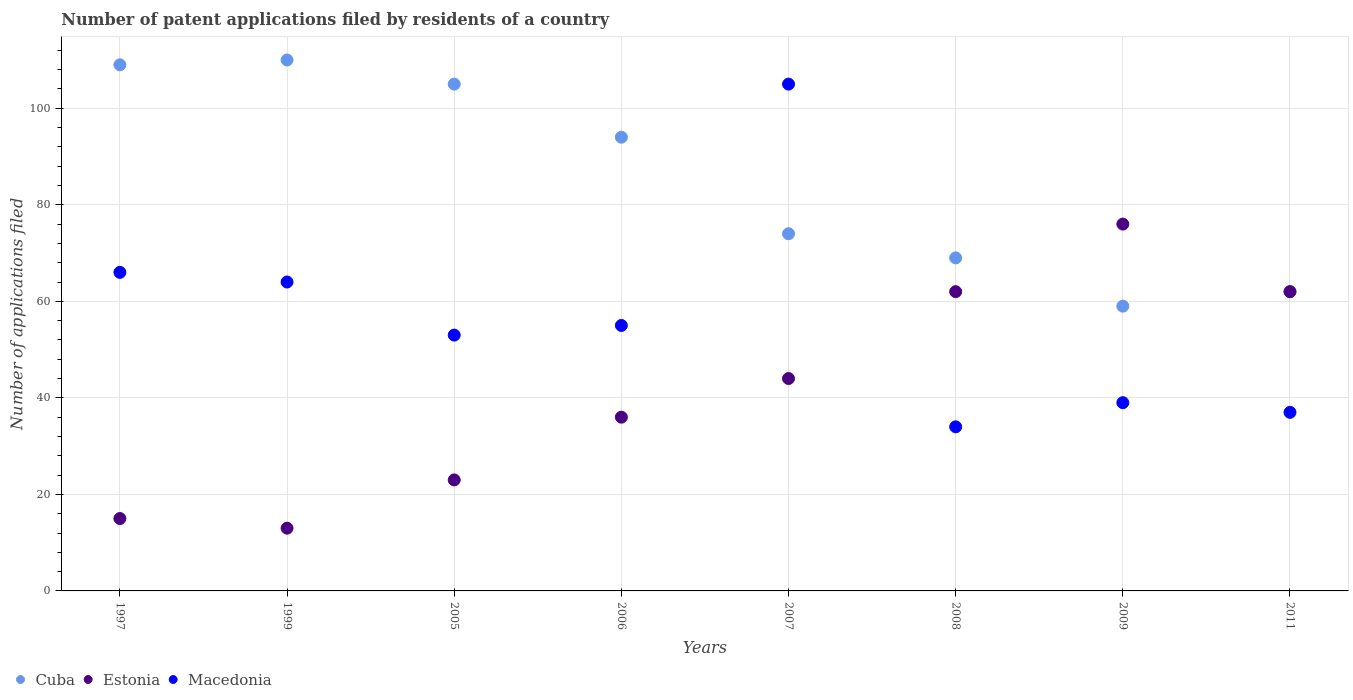How many different coloured dotlines are there?
Make the answer very short. 3. What is the number of applications filed in Cuba in 2009?
Provide a succinct answer. 59. Across all years, what is the minimum number of applications filed in Estonia?
Your answer should be very brief. 13. In which year was the number of applications filed in Cuba maximum?
Offer a very short reply. 1999. In which year was the number of applications filed in Estonia minimum?
Your response must be concise. 1999. What is the total number of applications filed in Macedonia in the graph?
Offer a terse response. 453. What is the difference between the number of applications filed in Estonia in 2008 and that in 2011?
Your response must be concise. 0. What is the average number of applications filed in Estonia per year?
Ensure brevity in your answer.  41.38. In the year 2009, what is the difference between the number of applications filed in Cuba and number of applications filed in Estonia?
Ensure brevity in your answer.  -17. What is the ratio of the number of applications filed in Cuba in 1997 to that in 2006?
Your answer should be compact. 1.16. Is the difference between the number of applications filed in Cuba in 2008 and 2009 greater than the difference between the number of applications filed in Estonia in 2008 and 2009?
Give a very brief answer. Yes. What is the difference between the highest and the lowest number of applications filed in Macedonia?
Your response must be concise. 71. In how many years, is the number of applications filed in Macedonia greater than the average number of applications filed in Macedonia taken over all years?
Make the answer very short. 3. Is the sum of the number of applications filed in Estonia in 1997 and 2008 greater than the maximum number of applications filed in Macedonia across all years?
Give a very brief answer. No. Is it the case that in every year, the sum of the number of applications filed in Estonia and number of applications filed in Cuba  is greater than the number of applications filed in Macedonia?
Your answer should be very brief. Yes. Does the number of applications filed in Estonia monotonically increase over the years?
Your answer should be compact. No. Is the number of applications filed in Cuba strictly greater than the number of applications filed in Estonia over the years?
Your response must be concise. No. How many dotlines are there?
Your answer should be very brief. 3. How many years are there in the graph?
Provide a short and direct response. 8. What is the difference between two consecutive major ticks on the Y-axis?
Your answer should be very brief. 20. Does the graph contain any zero values?
Provide a succinct answer. No. What is the title of the graph?
Provide a succinct answer. Number of patent applications filed by residents of a country. Does "Iran" appear as one of the legend labels in the graph?
Offer a terse response. No. What is the label or title of the Y-axis?
Your response must be concise. Number of applications filed. What is the Number of applications filed in Cuba in 1997?
Your response must be concise. 109. What is the Number of applications filed in Estonia in 1997?
Offer a very short reply. 15. What is the Number of applications filed in Cuba in 1999?
Give a very brief answer. 110. What is the Number of applications filed of Macedonia in 1999?
Keep it short and to the point. 64. What is the Number of applications filed in Cuba in 2005?
Your answer should be compact. 105. What is the Number of applications filed in Estonia in 2005?
Give a very brief answer. 23. What is the Number of applications filed of Macedonia in 2005?
Give a very brief answer. 53. What is the Number of applications filed of Cuba in 2006?
Your response must be concise. 94. What is the Number of applications filed of Cuba in 2007?
Ensure brevity in your answer.  74. What is the Number of applications filed in Estonia in 2007?
Provide a succinct answer. 44. What is the Number of applications filed in Macedonia in 2007?
Provide a short and direct response. 105. What is the Number of applications filed in Cuba in 2009?
Make the answer very short. 59. What is the Number of applications filed of Cuba in 2011?
Offer a very short reply. 62. What is the Number of applications filed in Macedonia in 2011?
Keep it short and to the point. 37. Across all years, what is the maximum Number of applications filed of Cuba?
Offer a very short reply. 110. Across all years, what is the maximum Number of applications filed in Macedonia?
Ensure brevity in your answer.  105. Across all years, what is the minimum Number of applications filed of Estonia?
Offer a very short reply. 13. Across all years, what is the minimum Number of applications filed in Macedonia?
Your response must be concise. 34. What is the total Number of applications filed of Cuba in the graph?
Ensure brevity in your answer.  682. What is the total Number of applications filed of Estonia in the graph?
Your answer should be compact. 331. What is the total Number of applications filed in Macedonia in the graph?
Ensure brevity in your answer.  453. What is the difference between the Number of applications filed in Estonia in 1997 and that in 1999?
Give a very brief answer. 2. What is the difference between the Number of applications filed of Macedonia in 1997 and that in 1999?
Ensure brevity in your answer.  2. What is the difference between the Number of applications filed in Estonia in 1997 and that in 2006?
Provide a succinct answer. -21. What is the difference between the Number of applications filed of Estonia in 1997 and that in 2007?
Your answer should be very brief. -29. What is the difference between the Number of applications filed of Macedonia in 1997 and that in 2007?
Ensure brevity in your answer.  -39. What is the difference between the Number of applications filed of Cuba in 1997 and that in 2008?
Keep it short and to the point. 40. What is the difference between the Number of applications filed in Estonia in 1997 and that in 2008?
Ensure brevity in your answer.  -47. What is the difference between the Number of applications filed in Macedonia in 1997 and that in 2008?
Offer a very short reply. 32. What is the difference between the Number of applications filed of Cuba in 1997 and that in 2009?
Your answer should be very brief. 50. What is the difference between the Number of applications filed in Estonia in 1997 and that in 2009?
Ensure brevity in your answer.  -61. What is the difference between the Number of applications filed in Macedonia in 1997 and that in 2009?
Your response must be concise. 27. What is the difference between the Number of applications filed of Cuba in 1997 and that in 2011?
Provide a succinct answer. 47. What is the difference between the Number of applications filed in Estonia in 1997 and that in 2011?
Your answer should be very brief. -47. What is the difference between the Number of applications filed in Macedonia in 1997 and that in 2011?
Ensure brevity in your answer.  29. What is the difference between the Number of applications filed of Cuba in 1999 and that in 2005?
Ensure brevity in your answer.  5. What is the difference between the Number of applications filed of Estonia in 1999 and that in 2005?
Your answer should be compact. -10. What is the difference between the Number of applications filed in Cuba in 1999 and that in 2006?
Your answer should be compact. 16. What is the difference between the Number of applications filed in Estonia in 1999 and that in 2006?
Ensure brevity in your answer.  -23. What is the difference between the Number of applications filed in Estonia in 1999 and that in 2007?
Your response must be concise. -31. What is the difference between the Number of applications filed in Macedonia in 1999 and that in 2007?
Make the answer very short. -41. What is the difference between the Number of applications filed in Cuba in 1999 and that in 2008?
Offer a very short reply. 41. What is the difference between the Number of applications filed in Estonia in 1999 and that in 2008?
Offer a very short reply. -49. What is the difference between the Number of applications filed of Macedonia in 1999 and that in 2008?
Make the answer very short. 30. What is the difference between the Number of applications filed in Cuba in 1999 and that in 2009?
Offer a very short reply. 51. What is the difference between the Number of applications filed of Estonia in 1999 and that in 2009?
Your response must be concise. -63. What is the difference between the Number of applications filed of Estonia in 1999 and that in 2011?
Your answer should be compact. -49. What is the difference between the Number of applications filed in Macedonia in 1999 and that in 2011?
Your answer should be very brief. 27. What is the difference between the Number of applications filed of Cuba in 2005 and that in 2007?
Offer a terse response. 31. What is the difference between the Number of applications filed of Estonia in 2005 and that in 2007?
Ensure brevity in your answer.  -21. What is the difference between the Number of applications filed of Macedonia in 2005 and that in 2007?
Ensure brevity in your answer.  -52. What is the difference between the Number of applications filed of Estonia in 2005 and that in 2008?
Offer a very short reply. -39. What is the difference between the Number of applications filed in Macedonia in 2005 and that in 2008?
Offer a very short reply. 19. What is the difference between the Number of applications filed of Estonia in 2005 and that in 2009?
Keep it short and to the point. -53. What is the difference between the Number of applications filed of Cuba in 2005 and that in 2011?
Keep it short and to the point. 43. What is the difference between the Number of applications filed in Estonia in 2005 and that in 2011?
Provide a short and direct response. -39. What is the difference between the Number of applications filed of Macedonia in 2005 and that in 2011?
Provide a succinct answer. 16. What is the difference between the Number of applications filed in Cuba in 2006 and that in 2007?
Offer a very short reply. 20. What is the difference between the Number of applications filed in Estonia in 2006 and that in 2007?
Your response must be concise. -8. What is the difference between the Number of applications filed of Cuba in 2006 and that in 2008?
Keep it short and to the point. 25. What is the difference between the Number of applications filed of Estonia in 2006 and that in 2008?
Keep it short and to the point. -26. What is the difference between the Number of applications filed of Macedonia in 2006 and that in 2008?
Ensure brevity in your answer.  21. What is the difference between the Number of applications filed in Cuba in 2006 and that in 2009?
Offer a terse response. 35. What is the difference between the Number of applications filed in Cuba in 2006 and that in 2011?
Your answer should be very brief. 32. What is the difference between the Number of applications filed in Estonia in 2006 and that in 2011?
Provide a succinct answer. -26. What is the difference between the Number of applications filed in Cuba in 2007 and that in 2008?
Make the answer very short. 5. What is the difference between the Number of applications filed of Macedonia in 2007 and that in 2008?
Provide a short and direct response. 71. What is the difference between the Number of applications filed in Estonia in 2007 and that in 2009?
Ensure brevity in your answer.  -32. What is the difference between the Number of applications filed in Macedonia in 2007 and that in 2009?
Provide a short and direct response. 66. What is the difference between the Number of applications filed of Cuba in 2007 and that in 2011?
Provide a short and direct response. 12. What is the difference between the Number of applications filed in Estonia in 2007 and that in 2011?
Provide a short and direct response. -18. What is the difference between the Number of applications filed in Macedonia in 2007 and that in 2011?
Your answer should be compact. 68. What is the difference between the Number of applications filed of Cuba in 2008 and that in 2009?
Make the answer very short. 10. What is the difference between the Number of applications filed of Estonia in 2008 and that in 2009?
Your response must be concise. -14. What is the difference between the Number of applications filed of Cuba in 2008 and that in 2011?
Offer a very short reply. 7. What is the difference between the Number of applications filed of Macedonia in 2008 and that in 2011?
Your answer should be very brief. -3. What is the difference between the Number of applications filed of Estonia in 2009 and that in 2011?
Provide a succinct answer. 14. What is the difference between the Number of applications filed of Cuba in 1997 and the Number of applications filed of Estonia in 1999?
Offer a very short reply. 96. What is the difference between the Number of applications filed of Estonia in 1997 and the Number of applications filed of Macedonia in 1999?
Ensure brevity in your answer.  -49. What is the difference between the Number of applications filed of Cuba in 1997 and the Number of applications filed of Estonia in 2005?
Keep it short and to the point. 86. What is the difference between the Number of applications filed of Estonia in 1997 and the Number of applications filed of Macedonia in 2005?
Offer a very short reply. -38. What is the difference between the Number of applications filed of Cuba in 1997 and the Number of applications filed of Estonia in 2007?
Your response must be concise. 65. What is the difference between the Number of applications filed in Estonia in 1997 and the Number of applications filed in Macedonia in 2007?
Your answer should be compact. -90. What is the difference between the Number of applications filed of Cuba in 1997 and the Number of applications filed of Estonia in 2008?
Give a very brief answer. 47. What is the difference between the Number of applications filed of Cuba in 1997 and the Number of applications filed of Macedonia in 2008?
Provide a succinct answer. 75. What is the difference between the Number of applications filed of Cuba in 1997 and the Number of applications filed of Estonia in 2009?
Your answer should be very brief. 33. What is the difference between the Number of applications filed in Cuba in 1997 and the Number of applications filed in Macedonia in 2009?
Provide a short and direct response. 70. What is the difference between the Number of applications filed of Estonia in 1997 and the Number of applications filed of Macedonia in 2011?
Make the answer very short. -22. What is the difference between the Number of applications filed in Cuba in 1999 and the Number of applications filed in Estonia in 2005?
Make the answer very short. 87. What is the difference between the Number of applications filed of Cuba in 1999 and the Number of applications filed of Macedonia in 2006?
Give a very brief answer. 55. What is the difference between the Number of applications filed in Estonia in 1999 and the Number of applications filed in Macedonia in 2006?
Give a very brief answer. -42. What is the difference between the Number of applications filed of Cuba in 1999 and the Number of applications filed of Estonia in 2007?
Ensure brevity in your answer.  66. What is the difference between the Number of applications filed of Cuba in 1999 and the Number of applications filed of Macedonia in 2007?
Offer a terse response. 5. What is the difference between the Number of applications filed in Estonia in 1999 and the Number of applications filed in Macedonia in 2007?
Provide a short and direct response. -92. What is the difference between the Number of applications filed in Cuba in 1999 and the Number of applications filed in Estonia in 2008?
Provide a short and direct response. 48. What is the difference between the Number of applications filed in Cuba in 1999 and the Number of applications filed in Macedonia in 2008?
Provide a succinct answer. 76. What is the difference between the Number of applications filed in Estonia in 1999 and the Number of applications filed in Macedonia in 2008?
Make the answer very short. -21. What is the difference between the Number of applications filed in Cuba in 1999 and the Number of applications filed in Macedonia in 2009?
Your answer should be very brief. 71. What is the difference between the Number of applications filed of Estonia in 1999 and the Number of applications filed of Macedonia in 2009?
Provide a short and direct response. -26. What is the difference between the Number of applications filed of Cuba in 1999 and the Number of applications filed of Estonia in 2011?
Provide a short and direct response. 48. What is the difference between the Number of applications filed in Estonia in 1999 and the Number of applications filed in Macedonia in 2011?
Make the answer very short. -24. What is the difference between the Number of applications filed of Cuba in 2005 and the Number of applications filed of Macedonia in 2006?
Keep it short and to the point. 50. What is the difference between the Number of applications filed in Estonia in 2005 and the Number of applications filed in Macedonia in 2006?
Your response must be concise. -32. What is the difference between the Number of applications filed in Cuba in 2005 and the Number of applications filed in Macedonia in 2007?
Ensure brevity in your answer.  0. What is the difference between the Number of applications filed in Estonia in 2005 and the Number of applications filed in Macedonia in 2007?
Keep it short and to the point. -82. What is the difference between the Number of applications filed of Cuba in 2005 and the Number of applications filed of Macedonia in 2008?
Your answer should be compact. 71. What is the difference between the Number of applications filed in Estonia in 2005 and the Number of applications filed in Macedonia in 2011?
Your response must be concise. -14. What is the difference between the Number of applications filed of Estonia in 2006 and the Number of applications filed of Macedonia in 2007?
Your answer should be very brief. -69. What is the difference between the Number of applications filed in Cuba in 2006 and the Number of applications filed in Macedonia in 2008?
Make the answer very short. 60. What is the difference between the Number of applications filed in Estonia in 2006 and the Number of applications filed in Macedonia in 2008?
Your answer should be very brief. 2. What is the difference between the Number of applications filed in Cuba in 2006 and the Number of applications filed in Estonia in 2009?
Ensure brevity in your answer.  18. What is the difference between the Number of applications filed of Cuba in 2006 and the Number of applications filed of Macedonia in 2009?
Make the answer very short. 55. What is the difference between the Number of applications filed of Estonia in 2006 and the Number of applications filed of Macedonia in 2009?
Your response must be concise. -3. What is the difference between the Number of applications filed in Cuba in 2006 and the Number of applications filed in Estonia in 2011?
Your answer should be compact. 32. What is the difference between the Number of applications filed of Cuba in 2006 and the Number of applications filed of Macedonia in 2011?
Your response must be concise. 57. What is the difference between the Number of applications filed of Cuba in 2007 and the Number of applications filed of Estonia in 2008?
Make the answer very short. 12. What is the difference between the Number of applications filed in Cuba in 2007 and the Number of applications filed in Macedonia in 2008?
Your answer should be compact. 40. What is the difference between the Number of applications filed of Cuba in 2007 and the Number of applications filed of Estonia in 2009?
Offer a very short reply. -2. What is the difference between the Number of applications filed of Cuba in 2007 and the Number of applications filed of Estonia in 2011?
Your answer should be compact. 12. What is the difference between the Number of applications filed of Estonia in 2007 and the Number of applications filed of Macedonia in 2011?
Make the answer very short. 7. What is the difference between the Number of applications filed of Cuba in 2008 and the Number of applications filed of Estonia in 2009?
Your answer should be compact. -7. What is the difference between the Number of applications filed of Estonia in 2008 and the Number of applications filed of Macedonia in 2009?
Provide a succinct answer. 23. What is the difference between the Number of applications filed of Cuba in 2008 and the Number of applications filed of Estonia in 2011?
Offer a very short reply. 7. What is the average Number of applications filed in Cuba per year?
Provide a succinct answer. 85.25. What is the average Number of applications filed in Estonia per year?
Provide a succinct answer. 41.38. What is the average Number of applications filed of Macedonia per year?
Your response must be concise. 56.62. In the year 1997, what is the difference between the Number of applications filed of Cuba and Number of applications filed of Estonia?
Your response must be concise. 94. In the year 1997, what is the difference between the Number of applications filed in Estonia and Number of applications filed in Macedonia?
Provide a succinct answer. -51. In the year 1999, what is the difference between the Number of applications filed in Cuba and Number of applications filed in Estonia?
Provide a succinct answer. 97. In the year 1999, what is the difference between the Number of applications filed of Estonia and Number of applications filed of Macedonia?
Provide a succinct answer. -51. In the year 2005, what is the difference between the Number of applications filed in Cuba and Number of applications filed in Estonia?
Your answer should be very brief. 82. In the year 2006, what is the difference between the Number of applications filed of Cuba and Number of applications filed of Macedonia?
Your response must be concise. 39. In the year 2006, what is the difference between the Number of applications filed in Estonia and Number of applications filed in Macedonia?
Provide a short and direct response. -19. In the year 2007, what is the difference between the Number of applications filed of Cuba and Number of applications filed of Estonia?
Make the answer very short. 30. In the year 2007, what is the difference between the Number of applications filed of Cuba and Number of applications filed of Macedonia?
Make the answer very short. -31. In the year 2007, what is the difference between the Number of applications filed of Estonia and Number of applications filed of Macedonia?
Give a very brief answer. -61. In the year 2008, what is the difference between the Number of applications filed in Cuba and Number of applications filed in Estonia?
Provide a succinct answer. 7. In the year 2008, what is the difference between the Number of applications filed in Estonia and Number of applications filed in Macedonia?
Provide a succinct answer. 28. In the year 2011, what is the difference between the Number of applications filed of Cuba and Number of applications filed of Macedonia?
Make the answer very short. 25. What is the ratio of the Number of applications filed of Cuba in 1997 to that in 1999?
Keep it short and to the point. 0.99. What is the ratio of the Number of applications filed of Estonia in 1997 to that in 1999?
Provide a succinct answer. 1.15. What is the ratio of the Number of applications filed of Macedonia in 1997 to that in 1999?
Give a very brief answer. 1.03. What is the ratio of the Number of applications filed of Cuba in 1997 to that in 2005?
Ensure brevity in your answer.  1.04. What is the ratio of the Number of applications filed in Estonia in 1997 to that in 2005?
Provide a short and direct response. 0.65. What is the ratio of the Number of applications filed of Macedonia in 1997 to that in 2005?
Provide a succinct answer. 1.25. What is the ratio of the Number of applications filed of Cuba in 1997 to that in 2006?
Keep it short and to the point. 1.16. What is the ratio of the Number of applications filed in Estonia in 1997 to that in 2006?
Your answer should be compact. 0.42. What is the ratio of the Number of applications filed of Macedonia in 1997 to that in 2006?
Offer a very short reply. 1.2. What is the ratio of the Number of applications filed of Cuba in 1997 to that in 2007?
Ensure brevity in your answer.  1.47. What is the ratio of the Number of applications filed in Estonia in 1997 to that in 2007?
Give a very brief answer. 0.34. What is the ratio of the Number of applications filed in Macedonia in 1997 to that in 2007?
Provide a short and direct response. 0.63. What is the ratio of the Number of applications filed of Cuba in 1997 to that in 2008?
Offer a very short reply. 1.58. What is the ratio of the Number of applications filed of Estonia in 1997 to that in 2008?
Give a very brief answer. 0.24. What is the ratio of the Number of applications filed in Macedonia in 1997 to that in 2008?
Your answer should be compact. 1.94. What is the ratio of the Number of applications filed in Cuba in 1997 to that in 2009?
Your answer should be very brief. 1.85. What is the ratio of the Number of applications filed in Estonia in 1997 to that in 2009?
Your answer should be compact. 0.2. What is the ratio of the Number of applications filed of Macedonia in 1997 to that in 2009?
Keep it short and to the point. 1.69. What is the ratio of the Number of applications filed of Cuba in 1997 to that in 2011?
Keep it short and to the point. 1.76. What is the ratio of the Number of applications filed in Estonia in 1997 to that in 2011?
Keep it short and to the point. 0.24. What is the ratio of the Number of applications filed in Macedonia in 1997 to that in 2011?
Keep it short and to the point. 1.78. What is the ratio of the Number of applications filed of Cuba in 1999 to that in 2005?
Your response must be concise. 1.05. What is the ratio of the Number of applications filed of Estonia in 1999 to that in 2005?
Ensure brevity in your answer.  0.57. What is the ratio of the Number of applications filed of Macedonia in 1999 to that in 2005?
Your response must be concise. 1.21. What is the ratio of the Number of applications filed in Cuba in 1999 to that in 2006?
Offer a terse response. 1.17. What is the ratio of the Number of applications filed in Estonia in 1999 to that in 2006?
Make the answer very short. 0.36. What is the ratio of the Number of applications filed in Macedonia in 1999 to that in 2006?
Your answer should be very brief. 1.16. What is the ratio of the Number of applications filed of Cuba in 1999 to that in 2007?
Keep it short and to the point. 1.49. What is the ratio of the Number of applications filed in Estonia in 1999 to that in 2007?
Provide a short and direct response. 0.3. What is the ratio of the Number of applications filed in Macedonia in 1999 to that in 2007?
Your response must be concise. 0.61. What is the ratio of the Number of applications filed of Cuba in 1999 to that in 2008?
Your answer should be very brief. 1.59. What is the ratio of the Number of applications filed in Estonia in 1999 to that in 2008?
Provide a short and direct response. 0.21. What is the ratio of the Number of applications filed in Macedonia in 1999 to that in 2008?
Your answer should be compact. 1.88. What is the ratio of the Number of applications filed of Cuba in 1999 to that in 2009?
Provide a short and direct response. 1.86. What is the ratio of the Number of applications filed in Estonia in 1999 to that in 2009?
Offer a very short reply. 0.17. What is the ratio of the Number of applications filed of Macedonia in 1999 to that in 2009?
Provide a succinct answer. 1.64. What is the ratio of the Number of applications filed in Cuba in 1999 to that in 2011?
Provide a short and direct response. 1.77. What is the ratio of the Number of applications filed of Estonia in 1999 to that in 2011?
Give a very brief answer. 0.21. What is the ratio of the Number of applications filed of Macedonia in 1999 to that in 2011?
Your answer should be compact. 1.73. What is the ratio of the Number of applications filed in Cuba in 2005 to that in 2006?
Your answer should be very brief. 1.12. What is the ratio of the Number of applications filed in Estonia in 2005 to that in 2006?
Keep it short and to the point. 0.64. What is the ratio of the Number of applications filed of Macedonia in 2005 to that in 2006?
Provide a succinct answer. 0.96. What is the ratio of the Number of applications filed in Cuba in 2005 to that in 2007?
Your answer should be very brief. 1.42. What is the ratio of the Number of applications filed of Estonia in 2005 to that in 2007?
Your answer should be very brief. 0.52. What is the ratio of the Number of applications filed in Macedonia in 2005 to that in 2007?
Provide a succinct answer. 0.5. What is the ratio of the Number of applications filed of Cuba in 2005 to that in 2008?
Your answer should be very brief. 1.52. What is the ratio of the Number of applications filed of Estonia in 2005 to that in 2008?
Offer a very short reply. 0.37. What is the ratio of the Number of applications filed of Macedonia in 2005 to that in 2008?
Provide a short and direct response. 1.56. What is the ratio of the Number of applications filed of Cuba in 2005 to that in 2009?
Offer a very short reply. 1.78. What is the ratio of the Number of applications filed of Estonia in 2005 to that in 2009?
Offer a very short reply. 0.3. What is the ratio of the Number of applications filed of Macedonia in 2005 to that in 2009?
Keep it short and to the point. 1.36. What is the ratio of the Number of applications filed in Cuba in 2005 to that in 2011?
Offer a very short reply. 1.69. What is the ratio of the Number of applications filed in Estonia in 2005 to that in 2011?
Offer a very short reply. 0.37. What is the ratio of the Number of applications filed in Macedonia in 2005 to that in 2011?
Give a very brief answer. 1.43. What is the ratio of the Number of applications filed in Cuba in 2006 to that in 2007?
Make the answer very short. 1.27. What is the ratio of the Number of applications filed of Estonia in 2006 to that in 2007?
Provide a succinct answer. 0.82. What is the ratio of the Number of applications filed in Macedonia in 2006 to that in 2007?
Give a very brief answer. 0.52. What is the ratio of the Number of applications filed of Cuba in 2006 to that in 2008?
Ensure brevity in your answer.  1.36. What is the ratio of the Number of applications filed of Estonia in 2006 to that in 2008?
Make the answer very short. 0.58. What is the ratio of the Number of applications filed of Macedonia in 2006 to that in 2008?
Your answer should be very brief. 1.62. What is the ratio of the Number of applications filed in Cuba in 2006 to that in 2009?
Ensure brevity in your answer.  1.59. What is the ratio of the Number of applications filed of Estonia in 2006 to that in 2009?
Ensure brevity in your answer.  0.47. What is the ratio of the Number of applications filed in Macedonia in 2006 to that in 2009?
Keep it short and to the point. 1.41. What is the ratio of the Number of applications filed of Cuba in 2006 to that in 2011?
Offer a terse response. 1.52. What is the ratio of the Number of applications filed of Estonia in 2006 to that in 2011?
Ensure brevity in your answer.  0.58. What is the ratio of the Number of applications filed of Macedonia in 2006 to that in 2011?
Your response must be concise. 1.49. What is the ratio of the Number of applications filed in Cuba in 2007 to that in 2008?
Your answer should be compact. 1.07. What is the ratio of the Number of applications filed in Estonia in 2007 to that in 2008?
Make the answer very short. 0.71. What is the ratio of the Number of applications filed of Macedonia in 2007 to that in 2008?
Your answer should be very brief. 3.09. What is the ratio of the Number of applications filed in Cuba in 2007 to that in 2009?
Keep it short and to the point. 1.25. What is the ratio of the Number of applications filed in Estonia in 2007 to that in 2009?
Provide a short and direct response. 0.58. What is the ratio of the Number of applications filed of Macedonia in 2007 to that in 2009?
Your answer should be very brief. 2.69. What is the ratio of the Number of applications filed of Cuba in 2007 to that in 2011?
Ensure brevity in your answer.  1.19. What is the ratio of the Number of applications filed of Estonia in 2007 to that in 2011?
Your answer should be compact. 0.71. What is the ratio of the Number of applications filed in Macedonia in 2007 to that in 2011?
Provide a short and direct response. 2.84. What is the ratio of the Number of applications filed of Cuba in 2008 to that in 2009?
Provide a short and direct response. 1.17. What is the ratio of the Number of applications filed in Estonia in 2008 to that in 2009?
Give a very brief answer. 0.82. What is the ratio of the Number of applications filed in Macedonia in 2008 to that in 2009?
Your answer should be compact. 0.87. What is the ratio of the Number of applications filed in Cuba in 2008 to that in 2011?
Offer a very short reply. 1.11. What is the ratio of the Number of applications filed in Estonia in 2008 to that in 2011?
Provide a succinct answer. 1. What is the ratio of the Number of applications filed in Macedonia in 2008 to that in 2011?
Provide a succinct answer. 0.92. What is the ratio of the Number of applications filed of Cuba in 2009 to that in 2011?
Provide a short and direct response. 0.95. What is the ratio of the Number of applications filed in Estonia in 2009 to that in 2011?
Your answer should be compact. 1.23. What is the ratio of the Number of applications filed of Macedonia in 2009 to that in 2011?
Ensure brevity in your answer.  1.05. What is the difference between the highest and the second highest Number of applications filed in Cuba?
Make the answer very short. 1. 